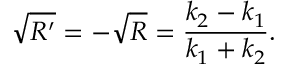<formula> <loc_0><loc_0><loc_500><loc_500>{ \sqrt { R ^ { \prime } } } = - { \sqrt { R } } = { \frac { k _ { 2 } - k _ { 1 } } { k _ { 1 } + k _ { 2 } } } .</formula> 